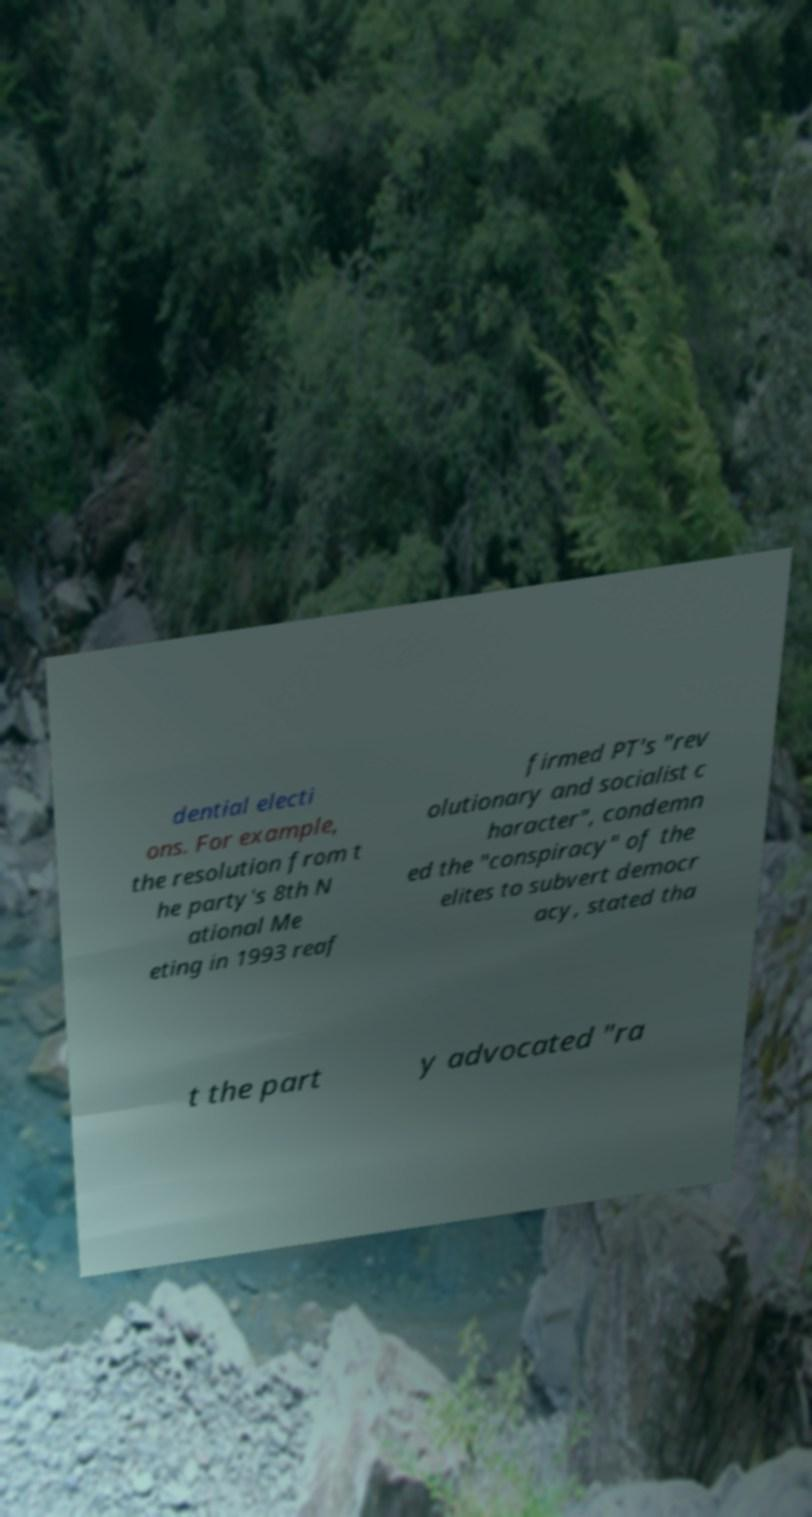What messages or text are displayed in this image? I need them in a readable, typed format. dential electi ons. For example, the resolution from t he party's 8th N ational Me eting in 1993 reaf firmed PT's "rev olutionary and socialist c haracter", condemn ed the "conspiracy" of the elites to subvert democr acy, stated tha t the part y advocated "ra 